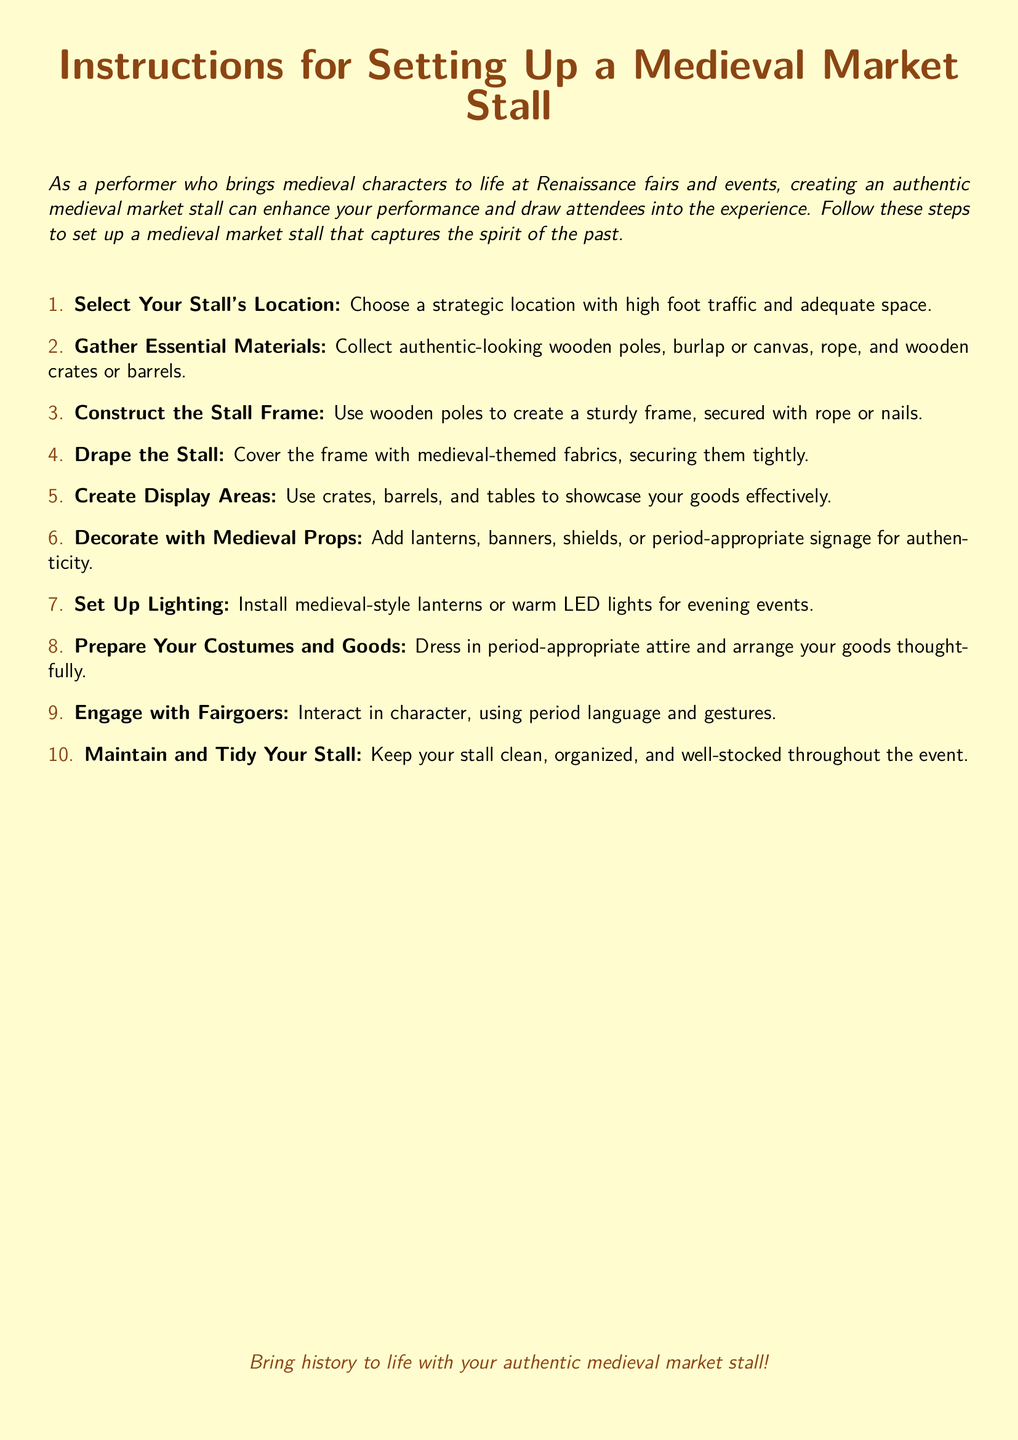What is the first step in setting up the stall? The first step involves selecting a location for the market stall.
Answer: Select Your Stall's Location How should the stall frame be secured? The document mentions using rope or nails to secure the frame.
Answer: Rope or nails What type of lighting is suggested for evening events? The instructions suggest using medieval-style lanterns or warm LED lights for evening setups.
Answer: Medieval-style lanterns or warm LED lights What materials are essential for the stall? The essential materials include wooden poles, burlap or canvas, rope, and wooden crates or barrels.
Answer: Wooden poles, burlap or canvas, rope, and wooden crates or barrels How many steps are outlined for setting up the stall? The document lists a total of ten steps for setting up the market stall.
Answer: Ten steps What should you do with your stall throughout the event? It is important to keep the stall clean, organized, and well-stocked throughout the event.
Answer: Maintain and tidy your stall What types of props are suggested for decoration? The instructions recommend adding lanterns, banners, shields, or period-appropriate signage.
Answer: Lanterns, banners, shields, or period-appropriate signage In which attire should vendors dress? The document indicates that vendors should dress in period-appropriate attire.
Answer: Period-appropriate attire What action is encouraged with fairgoers? The document encourages engaging with fairgoers while interacting in-character.
Answer: Engage with fairgoers 